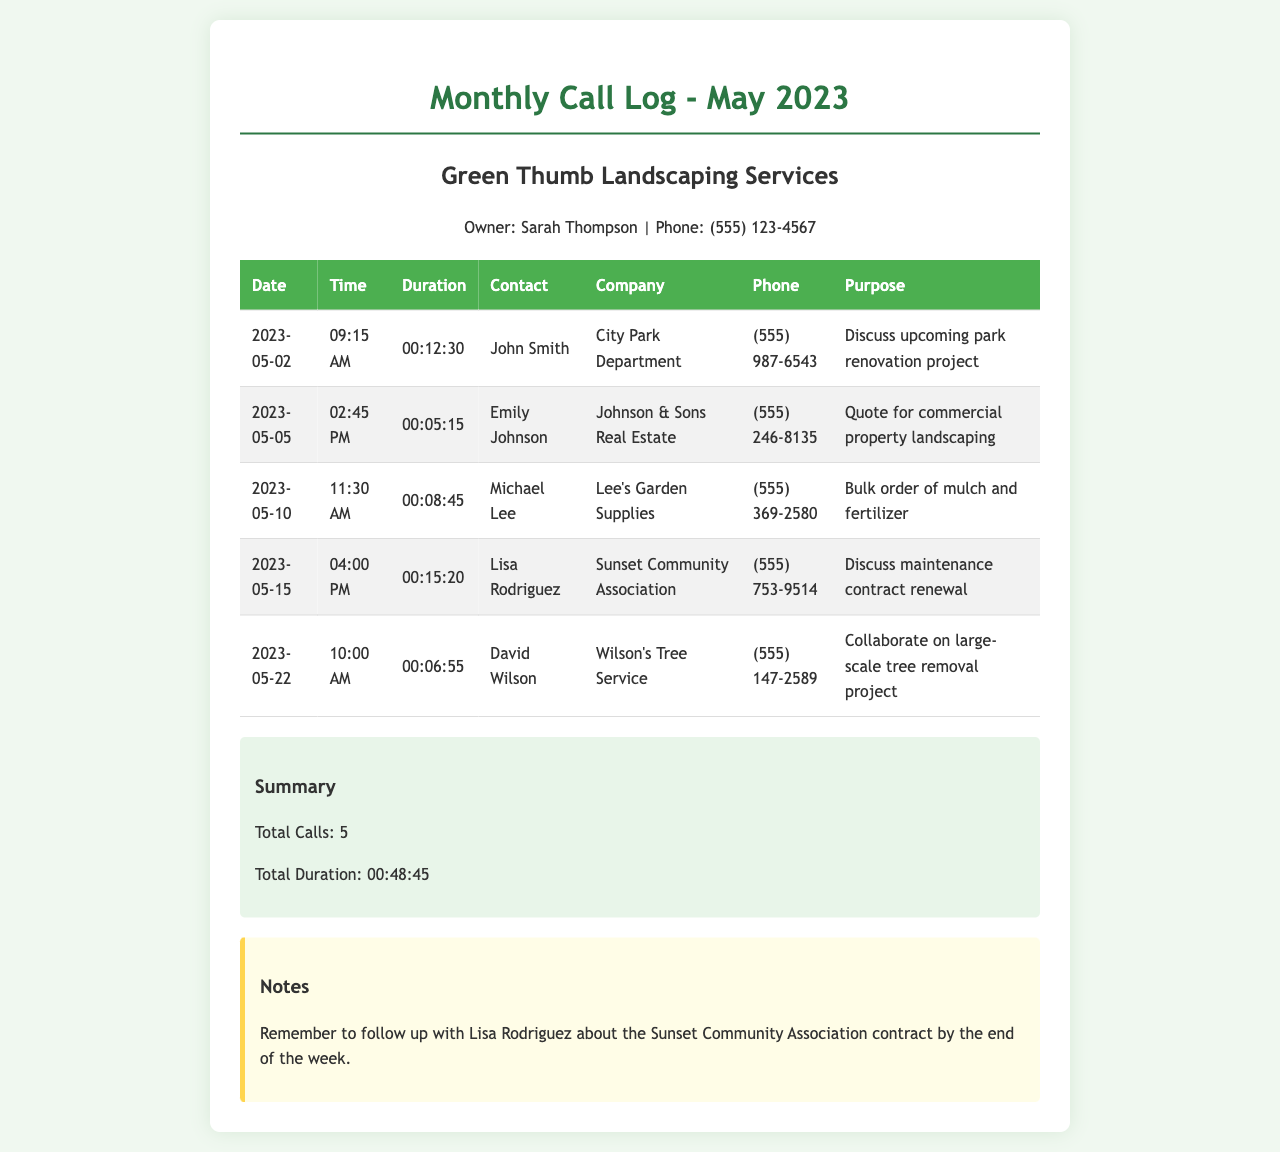What is the total number of calls? The total number of calls is listed in the summary section of the document, which states that there were 5 calls made.
Answer: 5 What was the longest call duration? The longest call duration can be inferred from the call details, with Lisa Rodriguez's call lasting 00:15:20.
Answer: 00:15:20 Who is the contact for the City Park Department? The contact name for the City Park Department is provided in the call log, which identifies John Smith as the contact.
Answer: John Smith What date was the call to Emily Johnson made? The date of the call to Emily Johnson is specified in the call log as 2023-05-05.
Answer: 2023-05-05 What is the purpose of the call with David Wilson? The purpose for the call with David Wilson is outlined in the logs, mentioning collaboration on a large-scale tree removal project.
Answer: Collaborate on large-scale tree removal project What is the total duration of all calls combined? The total duration of all calls is calculated and provided in the summary section, which totals 00:48:45.
Answer: 00:48:45 Which company did Michael Lee represent? The company represented by Michael Lee is mentioned in the call log as Lee's Garden Supplies.
Answer: Lee's Garden Supplies What reminder is noted in the document? The reminder mentioned in the notes section indicates a follow-up with Lisa Rodriguez regarding the Sunset Community Association contract.
Answer: Follow up with Lisa Rodriguez about the Sunset Community Association contract 